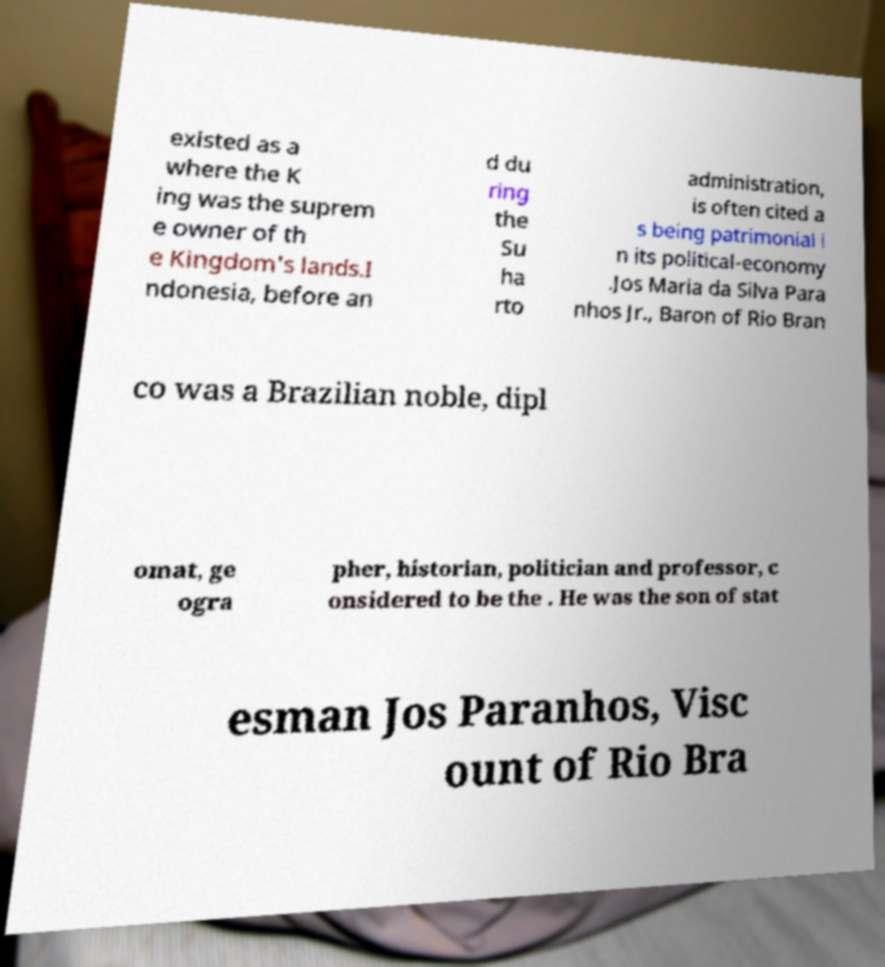Could you extract and type out the text from this image? existed as a where the K ing was the suprem e owner of th e Kingdom's lands.I ndonesia, before an d du ring the Su ha rto administration, is often cited a s being patrimonial i n its political-economy .Jos Maria da Silva Para nhos Jr., Baron of Rio Bran co was a Brazilian noble, dipl omat, ge ogra pher, historian, politician and professor, c onsidered to be the . He was the son of stat esman Jos Paranhos, Visc ount of Rio Bra 